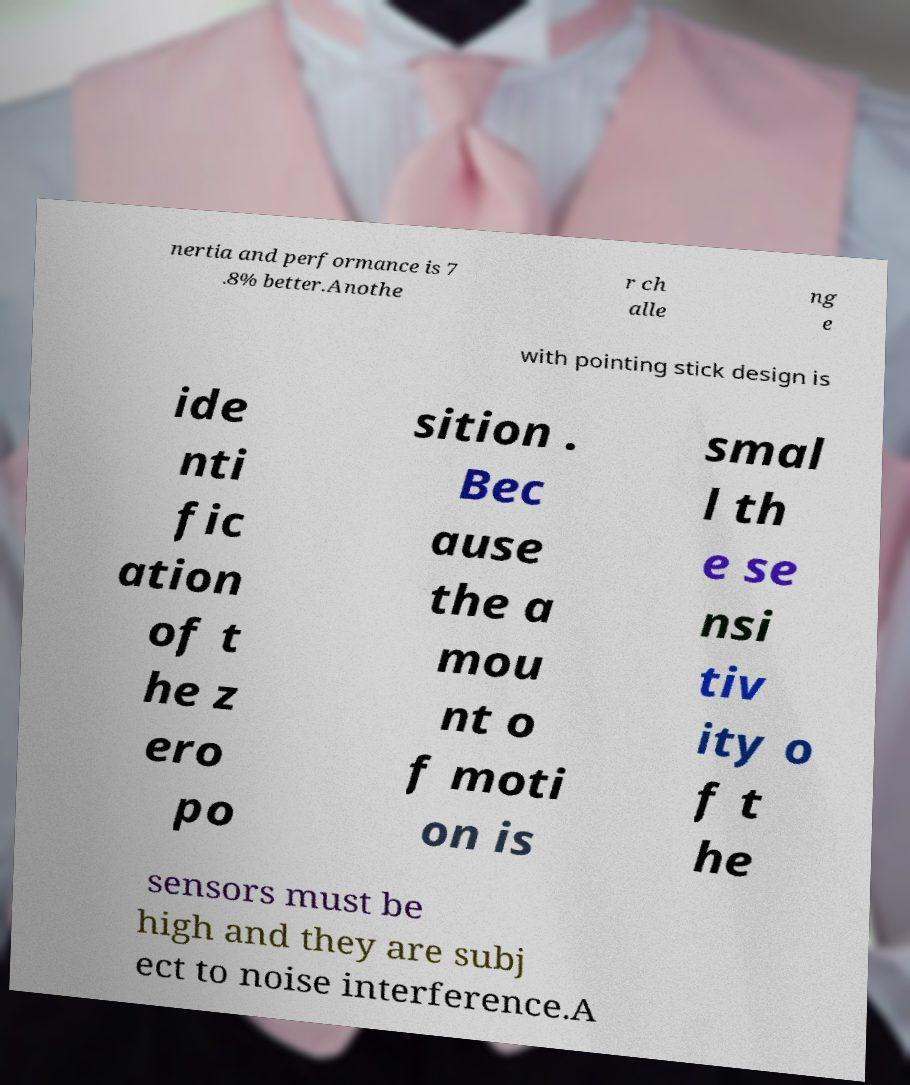I need the written content from this picture converted into text. Can you do that? nertia and performance is 7 .8% better.Anothe r ch alle ng e with pointing stick design is ide nti fic ation of t he z ero po sition . Bec ause the a mou nt o f moti on is smal l th e se nsi tiv ity o f t he sensors must be high and they are subj ect to noise interference.A 